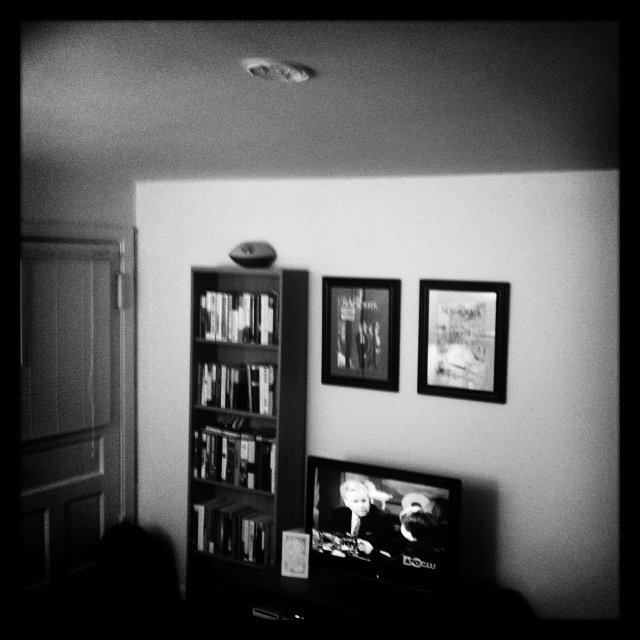Describe the objects in this image and their specific colors. I can see tv in black, lightgray, gray, and darkgray tones, book in black, gray, darkgray, and lightgray tones, book in black, lightgray, darkgray, and gray tones, sports ball in black, gray, darkgray, and lightgray tones, and book in black, darkgray, lightgray, and gray tones in this image. 